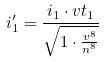<formula> <loc_0><loc_0><loc_500><loc_500>i _ { 1 } ^ { \prime } = \frac { i _ { 1 } \cdot v t _ { 1 } } { \sqrt { 1 \cdot \frac { v ^ { 8 } } { n ^ { 8 } } } }</formula> 